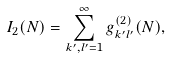<formula> <loc_0><loc_0><loc_500><loc_500>I _ { 2 } ( N ) = \sum _ { k ^ { \prime } , l ^ { \prime } = 1 } ^ { \infty } g _ { k ^ { \prime } l ^ { \prime } } ^ { ( 2 ) } ( N ) ,</formula> 